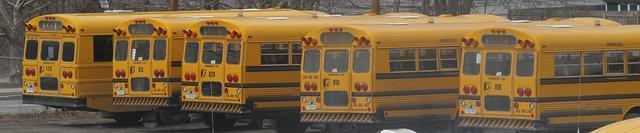How many buses are in this photo?
Give a very brief answer. 5. How many buses are there?
Give a very brief answer. 5. 